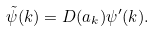<formula> <loc_0><loc_0><loc_500><loc_500>\tilde { \psi } ( k ) = D ( a _ { k } ) \psi ^ { \prime } ( k ) .</formula> 